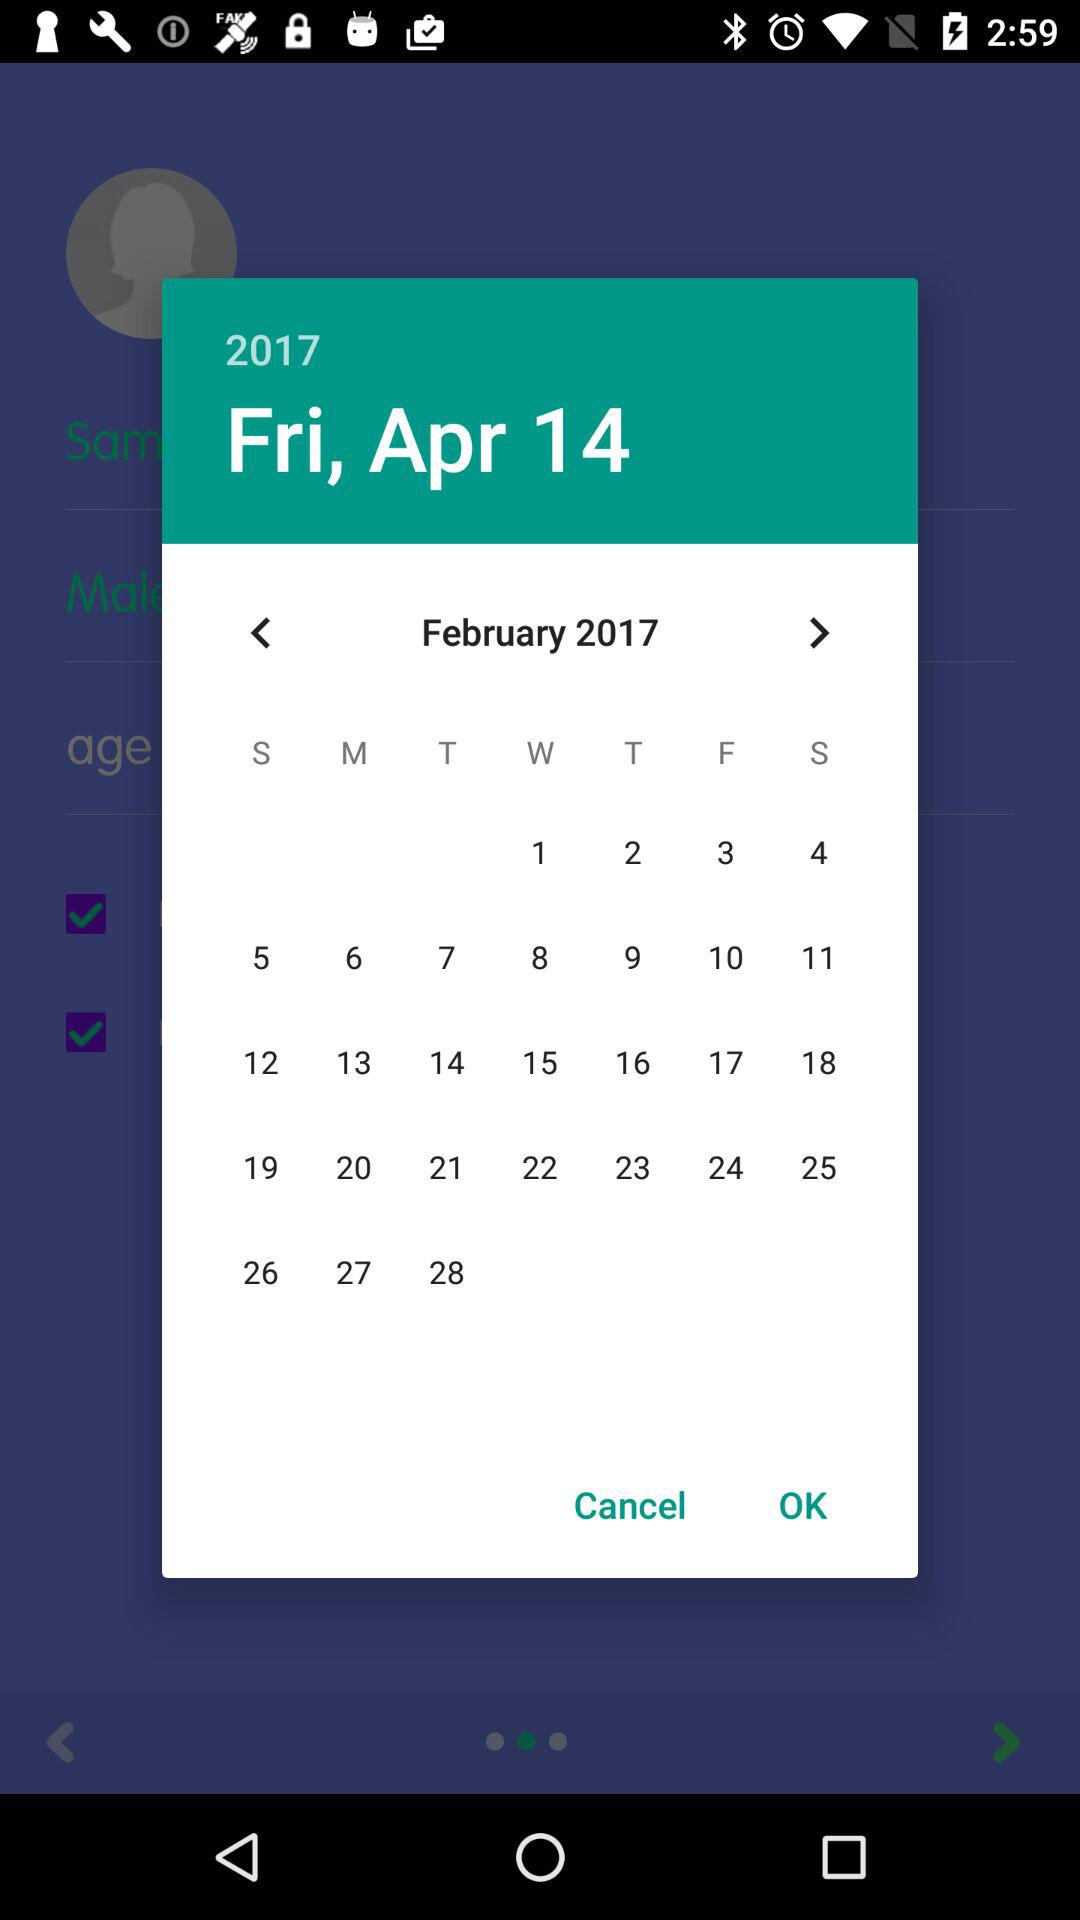What is the date given on the calendar? The given date is Friday, April 14, 2017. 